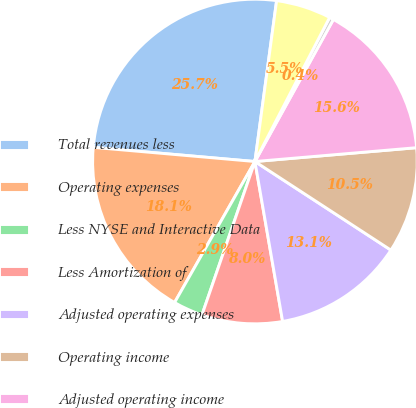Convert chart to OTSL. <chart><loc_0><loc_0><loc_500><loc_500><pie_chart><fcel>Total revenues less<fcel>Operating expenses<fcel>Less NYSE and Interactive Data<fcel>Less Amortization of<fcel>Adjusted operating expenses<fcel>Operating income<fcel>Adjusted operating income<fcel>Operating margin<fcel>Adjusted operating margin<nl><fcel>25.74%<fcel>18.15%<fcel>2.95%<fcel>8.02%<fcel>13.08%<fcel>10.55%<fcel>15.61%<fcel>0.42%<fcel>5.48%<nl></chart> 